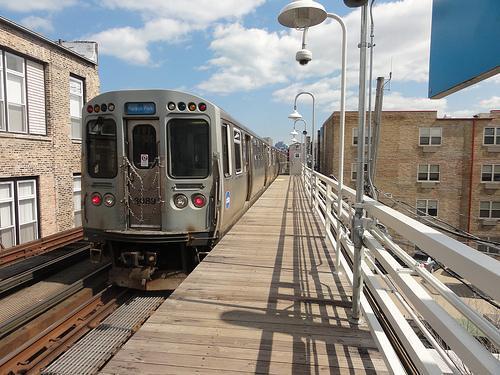How many trains in the picture?
Give a very brief answer. 1. 